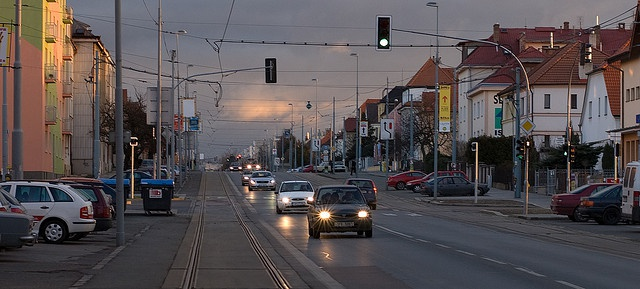Describe the objects in this image and their specific colors. I can see car in olive, black, and gray tones, car in olive, black, gray, and darkgray tones, car in olive, black, gray, and maroon tones, car in olive, black, gray, navy, and maroon tones, and car in olive, black, gray, blue, and darkblue tones in this image. 